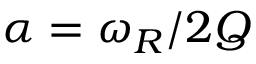<formula> <loc_0><loc_0><loc_500><loc_500>\alpha = \omega _ { R } \slash 2 Q</formula> 